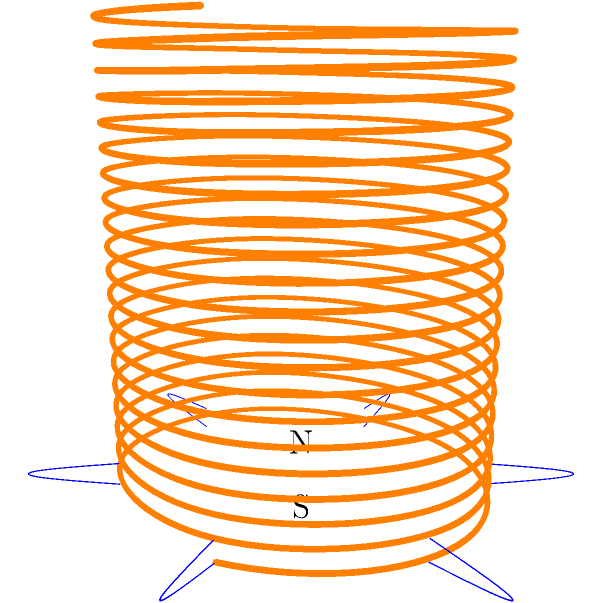Consider the solenoid shown in the 3D visualization above. Which statement best describes the magnetic field distribution inside and outside the solenoid when a steady current flows through it? To understand the magnetic field distribution around a solenoid, let's break it down step-by-step:

1. Inside the solenoid:
   - The magnetic field lines are parallel to the axis of the solenoid.
   - The field is uniform and strong throughout the interior.
   - The field strength is given by $B = \mu_0 n I$, where $\mu_0$ is the permeability of free space, $n$ is the number of turns per unit length, and $I$ is the current.

2. Outside the solenoid:
   - The field lines form closed loops around the solenoid.
   - The field strength decreases rapidly with distance from the solenoid.
   - At a distance much larger than the solenoid's radius, the field approximates that of a bar magnet.

3. At the ends of the solenoid:
   - The field lines spread out from one end (North pole) and converge at the other end (South pole).
   - This creates a non-uniform field near the ends, both inside and outside the solenoid.

4. Flux conservation:
   - The total magnetic flux is conserved, so the density of field lines is highest inside the solenoid where the field is strongest.

5. Right-hand rule:
   - The direction of the field follows the right-hand rule: if your right hand's fingers curl in the direction of current flow, your thumb points in the direction of the magnetic field inside the solenoid.

Based on these principles, we can conclude that the magnetic field is strong and uniform inside the solenoid, while outside it's weaker and resembles the field of a bar magnet, with field lines forming closed loops around the solenoid.
Answer: Strong and uniform inside, weak and dipole-like outside 